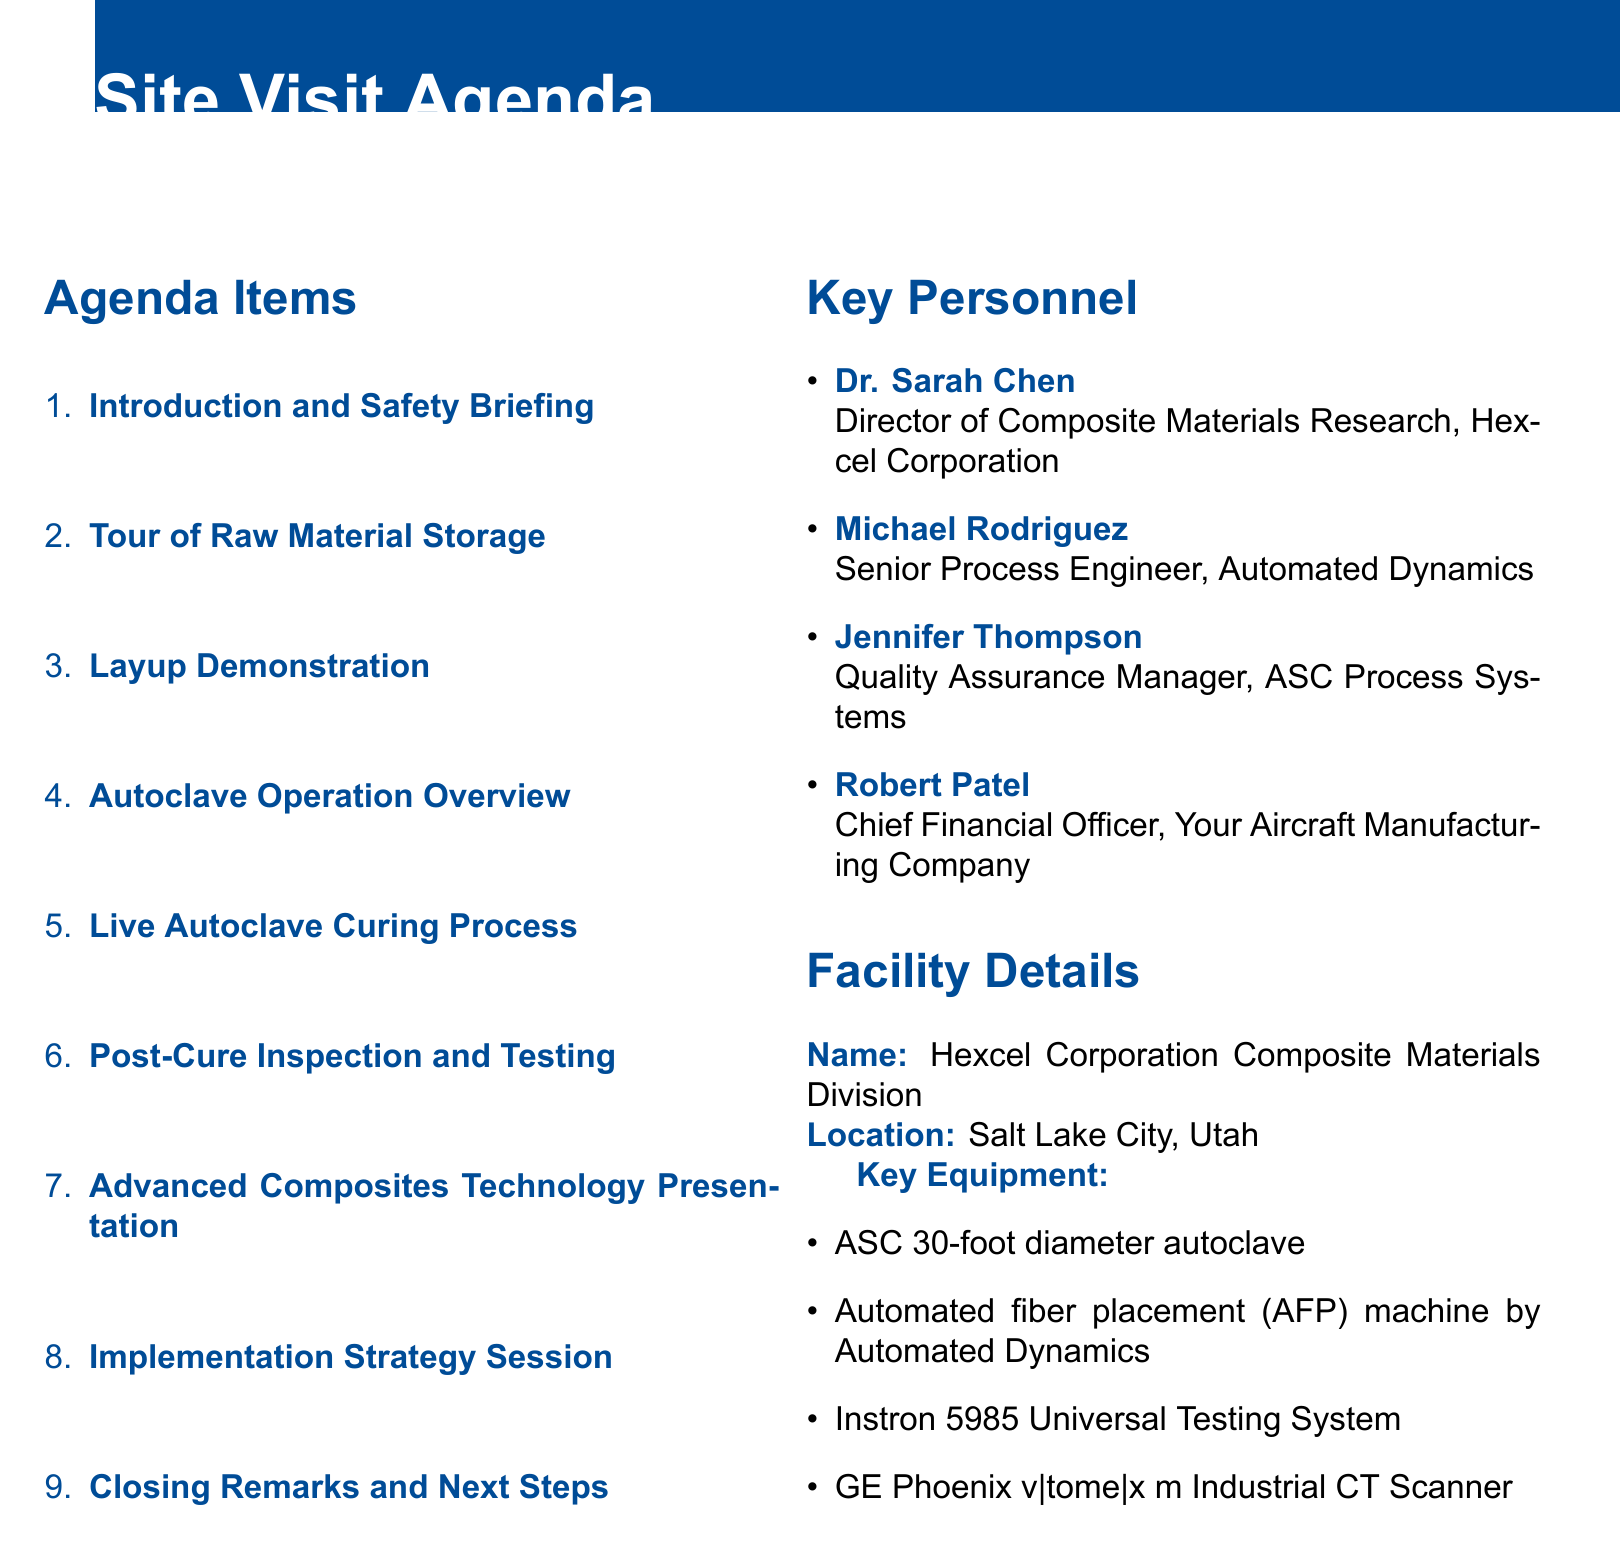What is the location of the facility? The location of the facility is explicitly stated in the document.
Answer: Salt Lake City, Utah Who is the Director of Composite Materials Research at Hexcel Corporation? This information is found in the section detailing the key personnel involved in the visit.
Answer: Dr. Sarah Chen How many agenda items are listed in the document? The total number of agenda items can be counted from the enumeration in the agenda items section.
Answer: 9 What autoclave is mentioned in the facility details? The specific autoclave mentioned in the facility details can be found listed under key equipment.
Answer: ASC 30-foot diameter autoclave What topic is covered in the "Implementation Strategy Session"? This agenda item contains a specific focus on strategy which can be inferred from the title and indicated details.
Answer: SWOT analysis Which company's prepreg system is showcased during the tour of raw material storage? The document specifies the company associated with the showcased prepreg system in that section.
Answer: Hexcel What testing methods are demonstrated after the curing process? This detail is included in the description of the inspection and testing that follows the curing process.
Answer: Non-destructive testing What is the position of Robert Patel in your aircraft manufacturing company? His job title is specified within the list of key personnel in the document.
Answer: Chief Financial Officer 